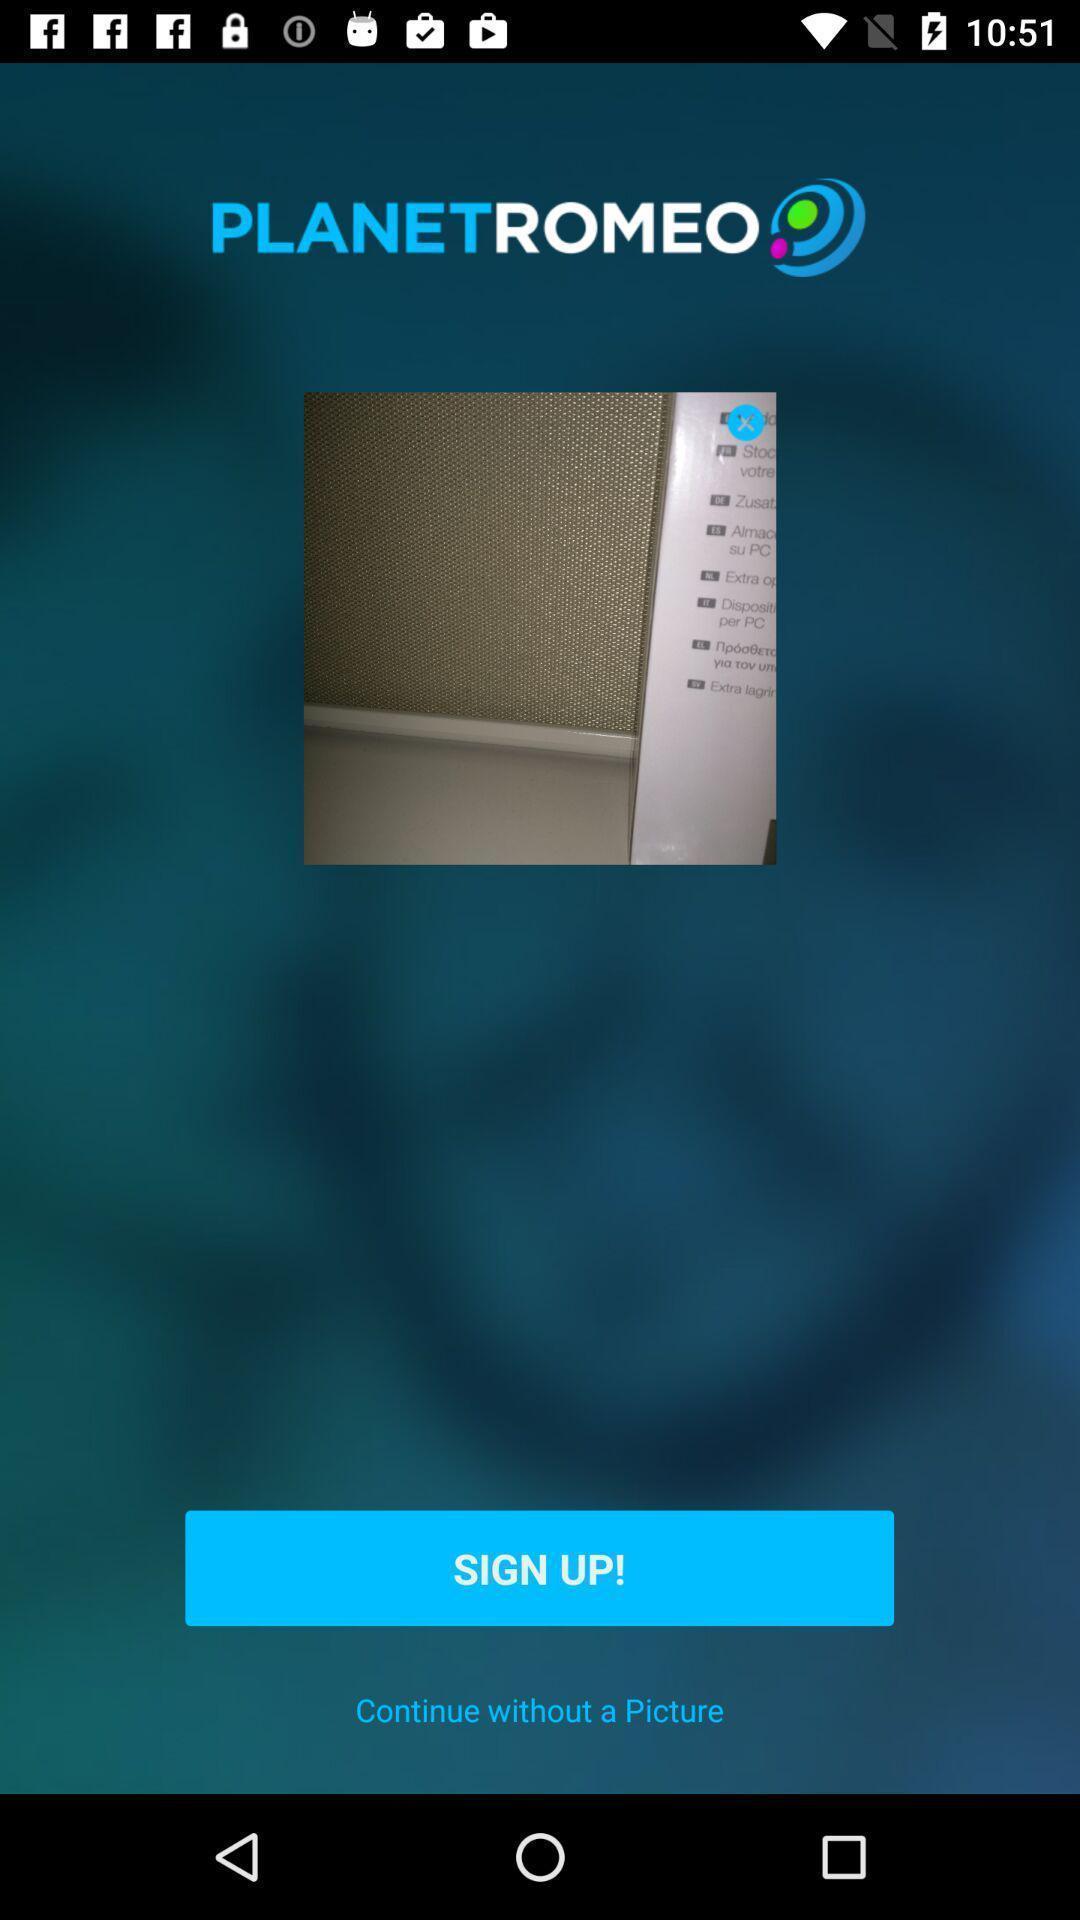What can you discern from this picture? Sign-up page of a dating app. 